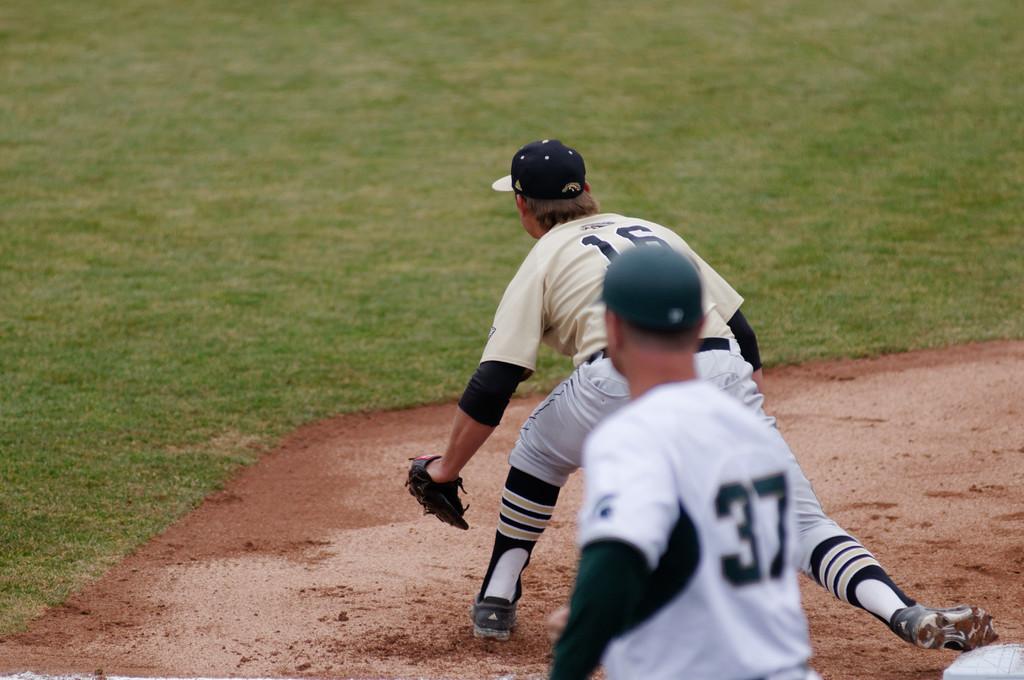What are the players' numbers?
Give a very brief answer. 16, 37. What number is the back player?
Your response must be concise. 37. 